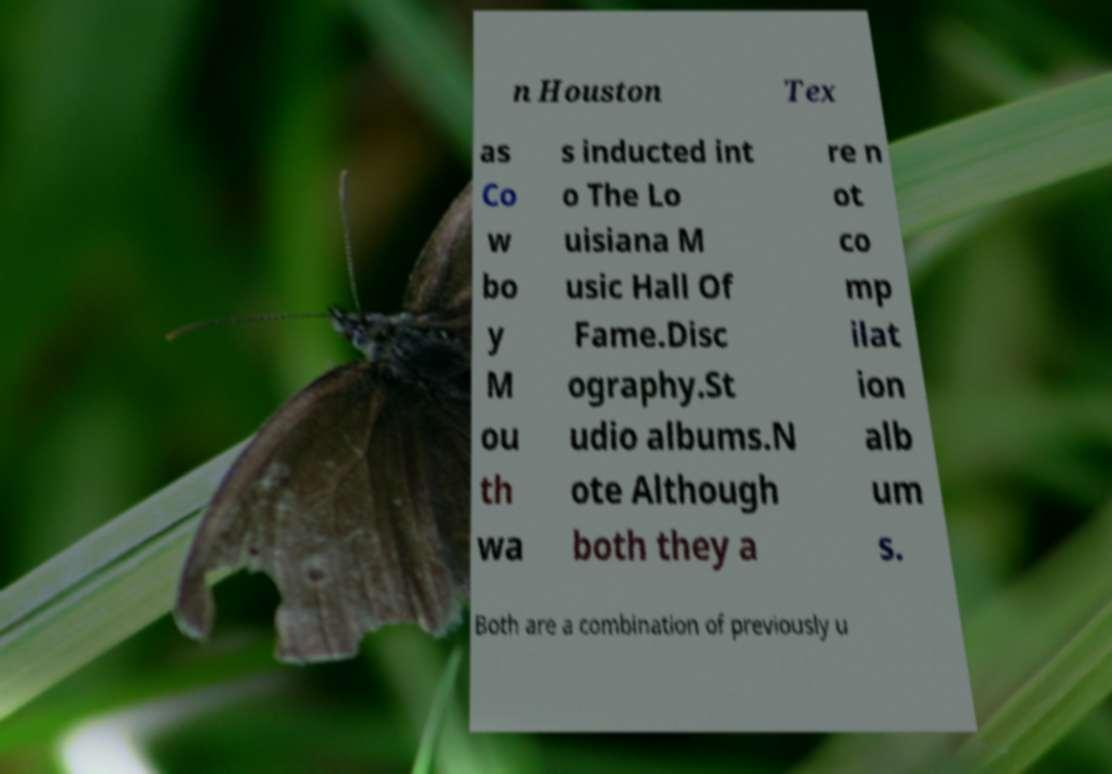Could you assist in decoding the text presented in this image and type it out clearly? n Houston Tex as Co w bo y M ou th wa s inducted int o The Lo uisiana M usic Hall Of Fame.Disc ography.St udio albums.N ote Although both they a re n ot co mp ilat ion alb um s. Both are a combination of previously u 